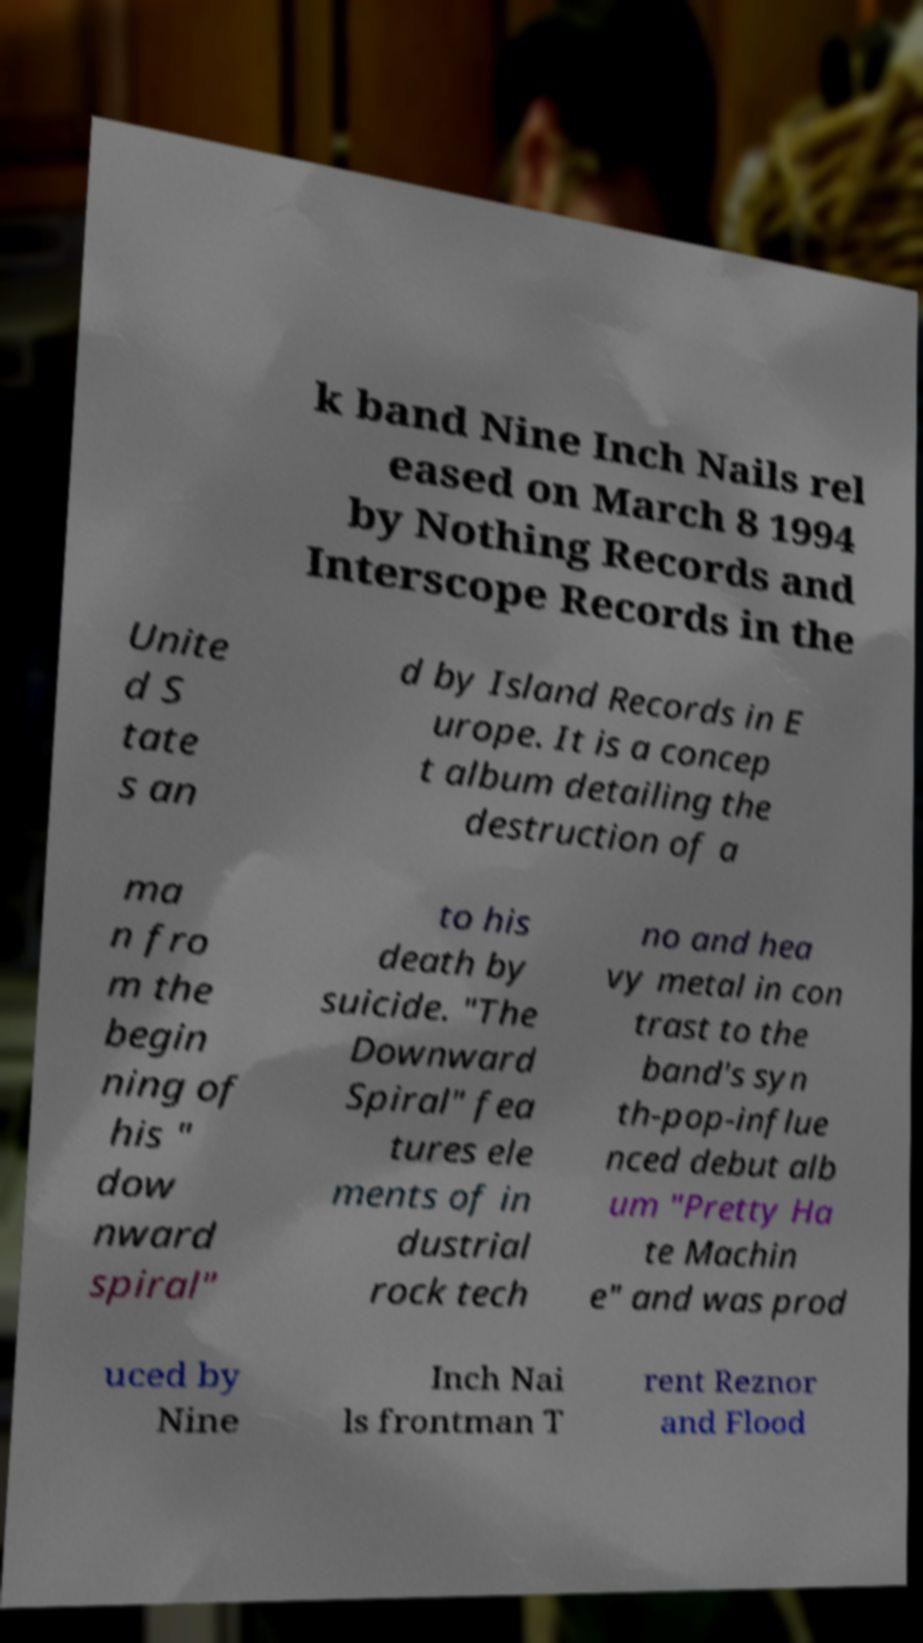Can you accurately transcribe the text from the provided image for me? k band Nine Inch Nails rel eased on March 8 1994 by Nothing Records and Interscope Records in the Unite d S tate s an d by Island Records in E urope. It is a concep t album detailing the destruction of a ma n fro m the begin ning of his " dow nward spiral" to his death by suicide. "The Downward Spiral" fea tures ele ments of in dustrial rock tech no and hea vy metal in con trast to the band's syn th-pop-influe nced debut alb um "Pretty Ha te Machin e" and was prod uced by Nine Inch Nai ls frontman T rent Reznor and Flood 